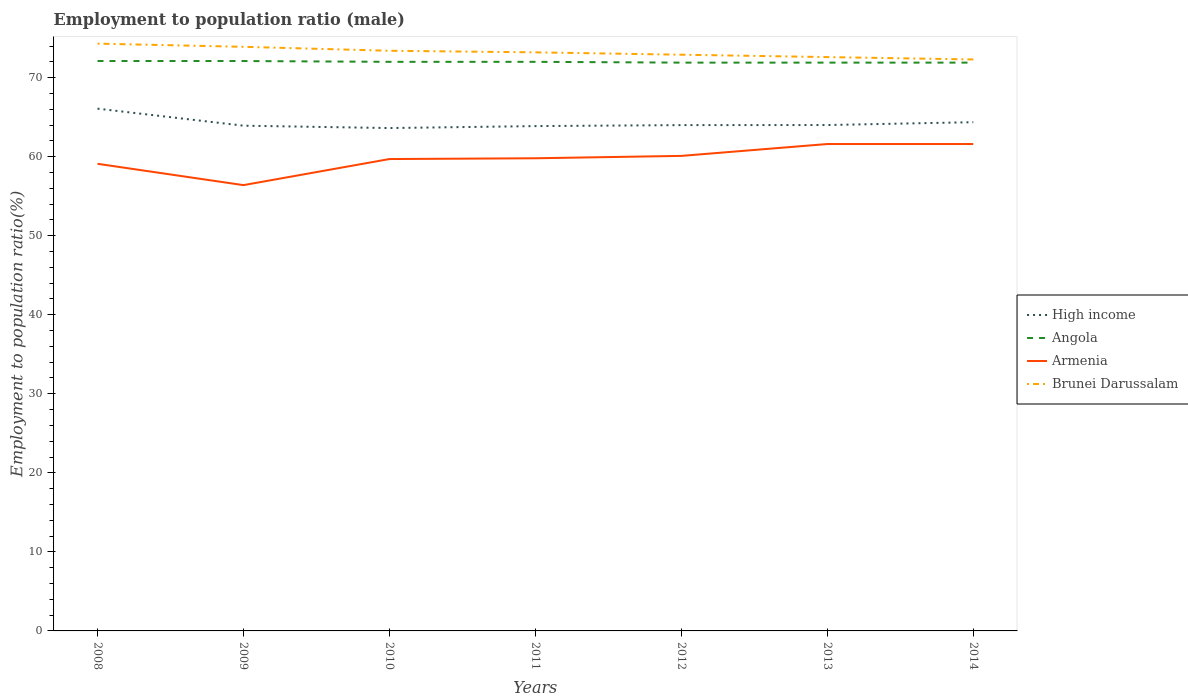Is the number of lines equal to the number of legend labels?
Offer a terse response. Yes. Across all years, what is the maximum employment to population ratio in Brunei Darussalam?
Ensure brevity in your answer.  72.3. What is the total employment to population ratio in Brunei Darussalam in the graph?
Make the answer very short. 0.6. What is the difference between the highest and the second highest employment to population ratio in High income?
Your answer should be compact. 2.46. Is the employment to population ratio in Angola strictly greater than the employment to population ratio in Brunei Darussalam over the years?
Offer a very short reply. Yes. What is the difference between two consecutive major ticks on the Y-axis?
Your response must be concise. 10. Are the values on the major ticks of Y-axis written in scientific E-notation?
Keep it short and to the point. No. Does the graph contain grids?
Your answer should be compact. No. How many legend labels are there?
Offer a terse response. 4. What is the title of the graph?
Make the answer very short. Employment to population ratio (male). Does "Mongolia" appear as one of the legend labels in the graph?
Your answer should be compact. No. What is the label or title of the Y-axis?
Your response must be concise. Employment to population ratio(%). What is the Employment to population ratio(%) of High income in 2008?
Make the answer very short. 66.08. What is the Employment to population ratio(%) in Angola in 2008?
Your answer should be compact. 72.1. What is the Employment to population ratio(%) of Armenia in 2008?
Keep it short and to the point. 59.1. What is the Employment to population ratio(%) of Brunei Darussalam in 2008?
Your answer should be very brief. 74.3. What is the Employment to population ratio(%) of High income in 2009?
Your response must be concise. 63.92. What is the Employment to population ratio(%) in Angola in 2009?
Make the answer very short. 72.1. What is the Employment to population ratio(%) of Armenia in 2009?
Keep it short and to the point. 56.4. What is the Employment to population ratio(%) in Brunei Darussalam in 2009?
Provide a succinct answer. 73.9. What is the Employment to population ratio(%) in High income in 2010?
Provide a succinct answer. 63.62. What is the Employment to population ratio(%) in Angola in 2010?
Provide a succinct answer. 72. What is the Employment to population ratio(%) of Armenia in 2010?
Keep it short and to the point. 59.7. What is the Employment to population ratio(%) of Brunei Darussalam in 2010?
Your answer should be compact. 73.4. What is the Employment to population ratio(%) of High income in 2011?
Keep it short and to the point. 63.87. What is the Employment to population ratio(%) of Angola in 2011?
Your answer should be very brief. 72. What is the Employment to population ratio(%) of Armenia in 2011?
Give a very brief answer. 59.8. What is the Employment to population ratio(%) of Brunei Darussalam in 2011?
Make the answer very short. 73.2. What is the Employment to population ratio(%) in High income in 2012?
Keep it short and to the point. 63.99. What is the Employment to population ratio(%) in Angola in 2012?
Ensure brevity in your answer.  71.9. What is the Employment to population ratio(%) of Armenia in 2012?
Ensure brevity in your answer.  60.1. What is the Employment to population ratio(%) of Brunei Darussalam in 2012?
Your answer should be very brief. 72.9. What is the Employment to population ratio(%) in High income in 2013?
Your answer should be compact. 64. What is the Employment to population ratio(%) of Angola in 2013?
Give a very brief answer. 71.9. What is the Employment to population ratio(%) in Armenia in 2013?
Ensure brevity in your answer.  61.6. What is the Employment to population ratio(%) of Brunei Darussalam in 2013?
Ensure brevity in your answer.  72.6. What is the Employment to population ratio(%) of High income in 2014?
Your response must be concise. 64.36. What is the Employment to population ratio(%) in Angola in 2014?
Offer a very short reply. 71.9. What is the Employment to population ratio(%) of Armenia in 2014?
Provide a short and direct response. 61.6. What is the Employment to population ratio(%) of Brunei Darussalam in 2014?
Provide a succinct answer. 72.3. Across all years, what is the maximum Employment to population ratio(%) in High income?
Your response must be concise. 66.08. Across all years, what is the maximum Employment to population ratio(%) in Angola?
Ensure brevity in your answer.  72.1. Across all years, what is the maximum Employment to population ratio(%) of Armenia?
Your answer should be very brief. 61.6. Across all years, what is the maximum Employment to population ratio(%) in Brunei Darussalam?
Make the answer very short. 74.3. Across all years, what is the minimum Employment to population ratio(%) of High income?
Your answer should be very brief. 63.62. Across all years, what is the minimum Employment to population ratio(%) in Angola?
Give a very brief answer. 71.9. Across all years, what is the minimum Employment to population ratio(%) of Armenia?
Offer a very short reply. 56.4. Across all years, what is the minimum Employment to population ratio(%) of Brunei Darussalam?
Your answer should be compact. 72.3. What is the total Employment to population ratio(%) in High income in the graph?
Your response must be concise. 449.85. What is the total Employment to population ratio(%) in Angola in the graph?
Offer a very short reply. 503.9. What is the total Employment to population ratio(%) of Armenia in the graph?
Make the answer very short. 418.3. What is the total Employment to population ratio(%) of Brunei Darussalam in the graph?
Ensure brevity in your answer.  512.6. What is the difference between the Employment to population ratio(%) of High income in 2008 and that in 2009?
Keep it short and to the point. 2.16. What is the difference between the Employment to population ratio(%) of Angola in 2008 and that in 2009?
Provide a short and direct response. 0. What is the difference between the Employment to population ratio(%) in Armenia in 2008 and that in 2009?
Provide a succinct answer. 2.7. What is the difference between the Employment to population ratio(%) of Brunei Darussalam in 2008 and that in 2009?
Provide a succinct answer. 0.4. What is the difference between the Employment to population ratio(%) of High income in 2008 and that in 2010?
Your answer should be compact. 2.46. What is the difference between the Employment to population ratio(%) of High income in 2008 and that in 2011?
Give a very brief answer. 2.21. What is the difference between the Employment to population ratio(%) in Angola in 2008 and that in 2011?
Make the answer very short. 0.1. What is the difference between the Employment to population ratio(%) of Armenia in 2008 and that in 2011?
Offer a terse response. -0.7. What is the difference between the Employment to population ratio(%) in High income in 2008 and that in 2012?
Your response must be concise. 2.08. What is the difference between the Employment to population ratio(%) in High income in 2008 and that in 2013?
Offer a very short reply. 2.07. What is the difference between the Employment to population ratio(%) of Brunei Darussalam in 2008 and that in 2013?
Your response must be concise. 1.7. What is the difference between the Employment to population ratio(%) in High income in 2008 and that in 2014?
Give a very brief answer. 1.71. What is the difference between the Employment to population ratio(%) in Brunei Darussalam in 2008 and that in 2014?
Give a very brief answer. 2. What is the difference between the Employment to population ratio(%) of High income in 2009 and that in 2010?
Your response must be concise. 0.3. What is the difference between the Employment to population ratio(%) in Armenia in 2009 and that in 2010?
Give a very brief answer. -3.3. What is the difference between the Employment to population ratio(%) in High income in 2009 and that in 2011?
Your answer should be compact. 0.05. What is the difference between the Employment to population ratio(%) in Angola in 2009 and that in 2011?
Provide a short and direct response. 0.1. What is the difference between the Employment to population ratio(%) of Brunei Darussalam in 2009 and that in 2011?
Your response must be concise. 0.7. What is the difference between the Employment to population ratio(%) in High income in 2009 and that in 2012?
Ensure brevity in your answer.  -0.07. What is the difference between the Employment to population ratio(%) in Brunei Darussalam in 2009 and that in 2012?
Your answer should be very brief. 1. What is the difference between the Employment to population ratio(%) of High income in 2009 and that in 2013?
Provide a succinct answer. -0.08. What is the difference between the Employment to population ratio(%) of Angola in 2009 and that in 2013?
Offer a very short reply. 0.2. What is the difference between the Employment to population ratio(%) in High income in 2009 and that in 2014?
Offer a terse response. -0.44. What is the difference between the Employment to population ratio(%) in Armenia in 2009 and that in 2014?
Keep it short and to the point. -5.2. What is the difference between the Employment to population ratio(%) of Brunei Darussalam in 2009 and that in 2014?
Offer a terse response. 1.6. What is the difference between the Employment to population ratio(%) of High income in 2010 and that in 2011?
Offer a very short reply. -0.25. What is the difference between the Employment to population ratio(%) in Armenia in 2010 and that in 2011?
Make the answer very short. -0.1. What is the difference between the Employment to population ratio(%) of High income in 2010 and that in 2012?
Your response must be concise. -0.37. What is the difference between the Employment to population ratio(%) in Angola in 2010 and that in 2012?
Your response must be concise. 0.1. What is the difference between the Employment to population ratio(%) of Armenia in 2010 and that in 2012?
Make the answer very short. -0.4. What is the difference between the Employment to population ratio(%) in Brunei Darussalam in 2010 and that in 2012?
Provide a succinct answer. 0.5. What is the difference between the Employment to population ratio(%) of High income in 2010 and that in 2013?
Your response must be concise. -0.38. What is the difference between the Employment to population ratio(%) in Angola in 2010 and that in 2013?
Your answer should be compact. 0.1. What is the difference between the Employment to population ratio(%) in High income in 2010 and that in 2014?
Your answer should be very brief. -0.74. What is the difference between the Employment to population ratio(%) in Angola in 2010 and that in 2014?
Provide a succinct answer. 0.1. What is the difference between the Employment to population ratio(%) in High income in 2011 and that in 2012?
Make the answer very short. -0.12. What is the difference between the Employment to population ratio(%) of Brunei Darussalam in 2011 and that in 2012?
Make the answer very short. 0.3. What is the difference between the Employment to population ratio(%) in High income in 2011 and that in 2013?
Give a very brief answer. -0.13. What is the difference between the Employment to population ratio(%) in Armenia in 2011 and that in 2013?
Make the answer very short. -1.8. What is the difference between the Employment to population ratio(%) of High income in 2011 and that in 2014?
Offer a very short reply. -0.49. What is the difference between the Employment to population ratio(%) in Armenia in 2011 and that in 2014?
Provide a short and direct response. -1.8. What is the difference between the Employment to population ratio(%) in Brunei Darussalam in 2011 and that in 2014?
Your answer should be compact. 0.9. What is the difference between the Employment to population ratio(%) of High income in 2012 and that in 2013?
Your answer should be compact. -0.01. What is the difference between the Employment to population ratio(%) of Angola in 2012 and that in 2013?
Your response must be concise. 0. What is the difference between the Employment to population ratio(%) of Armenia in 2012 and that in 2013?
Provide a short and direct response. -1.5. What is the difference between the Employment to population ratio(%) in High income in 2012 and that in 2014?
Provide a short and direct response. -0.37. What is the difference between the Employment to population ratio(%) in Angola in 2012 and that in 2014?
Give a very brief answer. 0. What is the difference between the Employment to population ratio(%) of Armenia in 2012 and that in 2014?
Offer a very short reply. -1.5. What is the difference between the Employment to population ratio(%) of High income in 2013 and that in 2014?
Ensure brevity in your answer.  -0.36. What is the difference between the Employment to population ratio(%) in Angola in 2013 and that in 2014?
Keep it short and to the point. 0. What is the difference between the Employment to population ratio(%) of High income in 2008 and the Employment to population ratio(%) of Angola in 2009?
Offer a very short reply. -6.02. What is the difference between the Employment to population ratio(%) in High income in 2008 and the Employment to population ratio(%) in Armenia in 2009?
Your response must be concise. 9.68. What is the difference between the Employment to population ratio(%) in High income in 2008 and the Employment to population ratio(%) in Brunei Darussalam in 2009?
Your response must be concise. -7.82. What is the difference between the Employment to population ratio(%) in Angola in 2008 and the Employment to population ratio(%) in Armenia in 2009?
Make the answer very short. 15.7. What is the difference between the Employment to population ratio(%) of Angola in 2008 and the Employment to population ratio(%) of Brunei Darussalam in 2009?
Your answer should be compact. -1.8. What is the difference between the Employment to population ratio(%) of Armenia in 2008 and the Employment to population ratio(%) of Brunei Darussalam in 2009?
Ensure brevity in your answer.  -14.8. What is the difference between the Employment to population ratio(%) in High income in 2008 and the Employment to population ratio(%) in Angola in 2010?
Offer a terse response. -5.92. What is the difference between the Employment to population ratio(%) of High income in 2008 and the Employment to population ratio(%) of Armenia in 2010?
Your response must be concise. 6.38. What is the difference between the Employment to population ratio(%) of High income in 2008 and the Employment to population ratio(%) of Brunei Darussalam in 2010?
Offer a very short reply. -7.32. What is the difference between the Employment to population ratio(%) in Angola in 2008 and the Employment to population ratio(%) in Armenia in 2010?
Your answer should be very brief. 12.4. What is the difference between the Employment to population ratio(%) in Angola in 2008 and the Employment to population ratio(%) in Brunei Darussalam in 2010?
Make the answer very short. -1.3. What is the difference between the Employment to population ratio(%) in Armenia in 2008 and the Employment to population ratio(%) in Brunei Darussalam in 2010?
Ensure brevity in your answer.  -14.3. What is the difference between the Employment to population ratio(%) of High income in 2008 and the Employment to population ratio(%) of Angola in 2011?
Provide a succinct answer. -5.92. What is the difference between the Employment to population ratio(%) of High income in 2008 and the Employment to population ratio(%) of Armenia in 2011?
Your answer should be very brief. 6.28. What is the difference between the Employment to population ratio(%) of High income in 2008 and the Employment to population ratio(%) of Brunei Darussalam in 2011?
Your response must be concise. -7.12. What is the difference between the Employment to population ratio(%) of Angola in 2008 and the Employment to population ratio(%) of Armenia in 2011?
Provide a short and direct response. 12.3. What is the difference between the Employment to population ratio(%) of Armenia in 2008 and the Employment to population ratio(%) of Brunei Darussalam in 2011?
Your response must be concise. -14.1. What is the difference between the Employment to population ratio(%) in High income in 2008 and the Employment to population ratio(%) in Angola in 2012?
Give a very brief answer. -5.82. What is the difference between the Employment to population ratio(%) in High income in 2008 and the Employment to population ratio(%) in Armenia in 2012?
Ensure brevity in your answer.  5.98. What is the difference between the Employment to population ratio(%) in High income in 2008 and the Employment to population ratio(%) in Brunei Darussalam in 2012?
Offer a terse response. -6.82. What is the difference between the Employment to population ratio(%) in Angola in 2008 and the Employment to population ratio(%) in Armenia in 2012?
Your answer should be compact. 12. What is the difference between the Employment to population ratio(%) in Angola in 2008 and the Employment to population ratio(%) in Brunei Darussalam in 2012?
Your answer should be very brief. -0.8. What is the difference between the Employment to population ratio(%) of Armenia in 2008 and the Employment to population ratio(%) of Brunei Darussalam in 2012?
Your answer should be very brief. -13.8. What is the difference between the Employment to population ratio(%) of High income in 2008 and the Employment to population ratio(%) of Angola in 2013?
Your answer should be compact. -5.82. What is the difference between the Employment to population ratio(%) of High income in 2008 and the Employment to population ratio(%) of Armenia in 2013?
Your answer should be very brief. 4.48. What is the difference between the Employment to population ratio(%) in High income in 2008 and the Employment to population ratio(%) in Brunei Darussalam in 2013?
Provide a short and direct response. -6.52. What is the difference between the Employment to population ratio(%) in Angola in 2008 and the Employment to population ratio(%) in Armenia in 2013?
Provide a succinct answer. 10.5. What is the difference between the Employment to population ratio(%) of Angola in 2008 and the Employment to population ratio(%) of Brunei Darussalam in 2013?
Ensure brevity in your answer.  -0.5. What is the difference between the Employment to population ratio(%) in High income in 2008 and the Employment to population ratio(%) in Angola in 2014?
Your response must be concise. -5.82. What is the difference between the Employment to population ratio(%) of High income in 2008 and the Employment to population ratio(%) of Armenia in 2014?
Ensure brevity in your answer.  4.48. What is the difference between the Employment to population ratio(%) in High income in 2008 and the Employment to population ratio(%) in Brunei Darussalam in 2014?
Make the answer very short. -6.22. What is the difference between the Employment to population ratio(%) of Angola in 2008 and the Employment to population ratio(%) of Armenia in 2014?
Provide a short and direct response. 10.5. What is the difference between the Employment to population ratio(%) of Armenia in 2008 and the Employment to population ratio(%) of Brunei Darussalam in 2014?
Your answer should be very brief. -13.2. What is the difference between the Employment to population ratio(%) in High income in 2009 and the Employment to population ratio(%) in Angola in 2010?
Your answer should be very brief. -8.08. What is the difference between the Employment to population ratio(%) in High income in 2009 and the Employment to population ratio(%) in Armenia in 2010?
Your answer should be very brief. 4.22. What is the difference between the Employment to population ratio(%) in High income in 2009 and the Employment to population ratio(%) in Brunei Darussalam in 2010?
Keep it short and to the point. -9.48. What is the difference between the Employment to population ratio(%) in Angola in 2009 and the Employment to population ratio(%) in Armenia in 2010?
Provide a short and direct response. 12.4. What is the difference between the Employment to population ratio(%) of Armenia in 2009 and the Employment to population ratio(%) of Brunei Darussalam in 2010?
Provide a short and direct response. -17. What is the difference between the Employment to population ratio(%) in High income in 2009 and the Employment to population ratio(%) in Angola in 2011?
Give a very brief answer. -8.08. What is the difference between the Employment to population ratio(%) of High income in 2009 and the Employment to population ratio(%) of Armenia in 2011?
Provide a short and direct response. 4.12. What is the difference between the Employment to population ratio(%) of High income in 2009 and the Employment to population ratio(%) of Brunei Darussalam in 2011?
Give a very brief answer. -9.28. What is the difference between the Employment to population ratio(%) of Angola in 2009 and the Employment to population ratio(%) of Armenia in 2011?
Keep it short and to the point. 12.3. What is the difference between the Employment to population ratio(%) in Angola in 2009 and the Employment to population ratio(%) in Brunei Darussalam in 2011?
Your answer should be very brief. -1.1. What is the difference between the Employment to population ratio(%) in Armenia in 2009 and the Employment to population ratio(%) in Brunei Darussalam in 2011?
Your answer should be very brief. -16.8. What is the difference between the Employment to population ratio(%) of High income in 2009 and the Employment to population ratio(%) of Angola in 2012?
Ensure brevity in your answer.  -7.98. What is the difference between the Employment to population ratio(%) in High income in 2009 and the Employment to population ratio(%) in Armenia in 2012?
Offer a terse response. 3.82. What is the difference between the Employment to population ratio(%) in High income in 2009 and the Employment to population ratio(%) in Brunei Darussalam in 2012?
Your answer should be compact. -8.98. What is the difference between the Employment to population ratio(%) of Armenia in 2009 and the Employment to population ratio(%) of Brunei Darussalam in 2012?
Give a very brief answer. -16.5. What is the difference between the Employment to population ratio(%) in High income in 2009 and the Employment to population ratio(%) in Angola in 2013?
Give a very brief answer. -7.98. What is the difference between the Employment to population ratio(%) of High income in 2009 and the Employment to population ratio(%) of Armenia in 2013?
Keep it short and to the point. 2.32. What is the difference between the Employment to population ratio(%) of High income in 2009 and the Employment to population ratio(%) of Brunei Darussalam in 2013?
Provide a short and direct response. -8.68. What is the difference between the Employment to population ratio(%) of Angola in 2009 and the Employment to population ratio(%) of Armenia in 2013?
Offer a terse response. 10.5. What is the difference between the Employment to population ratio(%) in Angola in 2009 and the Employment to population ratio(%) in Brunei Darussalam in 2013?
Keep it short and to the point. -0.5. What is the difference between the Employment to population ratio(%) in Armenia in 2009 and the Employment to population ratio(%) in Brunei Darussalam in 2013?
Your answer should be compact. -16.2. What is the difference between the Employment to population ratio(%) in High income in 2009 and the Employment to population ratio(%) in Angola in 2014?
Offer a terse response. -7.98. What is the difference between the Employment to population ratio(%) in High income in 2009 and the Employment to population ratio(%) in Armenia in 2014?
Provide a short and direct response. 2.32. What is the difference between the Employment to population ratio(%) of High income in 2009 and the Employment to population ratio(%) of Brunei Darussalam in 2014?
Offer a very short reply. -8.38. What is the difference between the Employment to population ratio(%) in Angola in 2009 and the Employment to population ratio(%) in Armenia in 2014?
Provide a succinct answer. 10.5. What is the difference between the Employment to population ratio(%) in Angola in 2009 and the Employment to population ratio(%) in Brunei Darussalam in 2014?
Provide a short and direct response. -0.2. What is the difference between the Employment to population ratio(%) in Armenia in 2009 and the Employment to population ratio(%) in Brunei Darussalam in 2014?
Offer a terse response. -15.9. What is the difference between the Employment to population ratio(%) of High income in 2010 and the Employment to population ratio(%) of Angola in 2011?
Make the answer very short. -8.38. What is the difference between the Employment to population ratio(%) of High income in 2010 and the Employment to population ratio(%) of Armenia in 2011?
Keep it short and to the point. 3.82. What is the difference between the Employment to population ratio(%) of High income in 2010 and the Employment to population ratio(%) of Brunei Darussalam in 2011?
Ensure brevity in your answer.  -9.58. What is the difference between the Employment to population ratio(%) of High income in 2010 and the Employment to population ratio(%) of Angola in 2012?
Give a very brief answer. -8.28. What is the difference between the Employment to population ratio(%) in High income in 2010 and the Employment to population ratio(%) in Armenia in 2012?
Make the answer very short. 3.52. What is the difference between the Employment to population ratio(%) in High income in 2010 and the Employment to population ratio(%) in Brunei Darussalam in 2012?
Make the answer very short. -9.28. What is the difference between the Employment to population ratio(%) of Angola in 2010 and the Employment to population ratio(%) of Brunei Darussalam in 2012?
Ensure brevity in your answer.  -0.9. What is the difference between the Employment to population ratio(%) of Armenia in 2010 and the Employment to population ratio(%) of Brunei Darussalam in 2012?
Provide a short and direct response. -13.2. What is the difference between the Employment to population ratio(%) in High income in 2010 and the Employment to population ratio(%) in Angola in 2013?
Offer a very short reply. -8.28. What is the difference between the Employment to population ratio(%) in High income in 2010 and the Employment to population ratio(%) in Armenia in 2013?
Your answer should be very brief. 2.02. What is the difference between the Employment to population ratio(%) in High income in 2010 and the Employment to population ratio(%) in Brunei Darussalam in 2013?
Your response must be concise. -8.98. What is the difference between the Employment to population ratio(%) of Armenia in 2010 and the Employment to population ratio(%) of Brunei Darussalam in 2013?
Your answer should be very brief. -12.9. What is the difference between the Employment to population ratio(%) of High income in 2010 and the Employment to population ratio(%) of Angola in 2014?
Make the answer very short. -8.28. What is the difference between the Employment to population ratio(%) of High income in 2010 and the Employment to population ratio(%) of Armenia in 2014?
Offer a very short reply. 2.02. What is the difference between the Employment to population ratio(%) of High income in 2010 and the Employment to population ratio(%) of Brunei Darussalam in 2014?
Offer a very short reply. -8.68. What is the difference between the Employment to population ratio(%) of Angola in 2010 and the Employment to population ratio(%) of Brunei Darussalam in 2014?
Your response must be concise. -0.3. What is the difference between the Employment to population ratio(%) in High income in 2011 and the Employment to population ratio(%) in Angola in 2012?
Provide a succinct answer. -8.03. What is the difference between the Employment to population ratio(%) in High income in 2011 and the Employment to population ratio(%) in Armenia in 2012?
Keep it short and to the point. 3.77. What is the difference between the Employment to population ratio(%) of High income in 2011 and the Employment to population ratio(%) of Brunei Darussalam in 2012?
Offer a terse response. -9.03. What is the difference between the Employment to population ratio(%) in Angola in 2011 and the Employment to population ratio(%) in Armenia in 2012?
Your response must be concise. 11.9. What is the difference between the Employment to population ratio(%) in Armenia in 2011 and the Employment to population ratio(%) in Brunei Darussalam in 2012?
Your answer should be very brief. -13.1. What is the difference between the Employment to population ratio(%) in High income in 2011 and the Employment to population ratio(%) in Angola in 2013?
Offer a very short reply. -8.03. What is the difference between the Employment to population ratio(%) in High income in 2011 and the Employment to population ratio(%) in Armenia in 2013?
Provide a short and direct response. 2.27. What is the difference between the Employment to population ratio(%) in High income in 2011 and the Employment to population ratio(%) in Brunei Darussalam in 2013?
Your answer should be very brief. -8.73. What is the difference between the Employment to population ratio(%) in Angola in 2011 and the Employment to population ratio(%) in Armenia in 2013?
Offer a terse response. 10.4. What is the difference between the Employment to population ratio(%) in Angola in 2011 and the Employment to population ratio(%) in Brunei Darussalam in 2013?
Ensure brevity in your answer.  -0.6. What is the difference between the Employment to population ratio(%) of High income in 2011 and the Employment to population ratio(%) of Angola in 2014?
Your answer should be compact. -8.03. What is the difference between the Employment to population ratio(%) in High income in 2011 and the Employment to population ratio(%) in Armenia in 2014?
Offer a very short reply. 2.27. What is the difference between the Employment to population ratio(%) of High income in 2011 and the Employment to population ratio(%) of Brunei Darussalam in 2014?
Keep it short and to the point. -8.43. What is the difference between the Employment to population ratio(%) in Angola in 2011 and the Employment to population ratio(%) in Brunei Darussalam in 2014?
Offer a very short reply. -0.3. What is the difference between the Employment to population ratio(%) of High income in 2012 and the Employment to population ratio(%) of Angola in 2013?
Offer a very short reply. -7.91. What is the difference between the Employment to population ratio(%) in High income in 2012 and the Employment to population ratio(%) in Armenia in 2013?
Offer a very short reply. 2.39. What is the difference between the Employment to population ratio(%) of High income in 2012 and the Employment to population ratio(%) of Brunei Darussalam in 2013?
Provide a succinct answer. -8.61. What is the difference between the Employment to population ratio(%) of Angola in 2012 and the Employment to population ratio(%) of Armenia in 2013?
Offer a terse response. 10.3. What is the difference between the Employment to population ratio(%) in High income in 2012 and the Employment to population ratio(%) in Angola in 2014?
Give a very brief answer. -7.91. What is the difference between the Employment to population ratio(%) of High income in 2012 and the Employment to population ratio(%) of Armenia in 2014?
Provide a short and direct response. 2.39. What is the difference between the Employment to population ratio(%) of High income in 2012 and the Employment to population ratio(%) of Brunei Darussalam in 2014?
Provide a succinct answer. -8.31. What is the difference between the Employment to population ratio(%) in Angola in 2012 and the Employment to population ratio(%) in Armenia in 2014?
Offer a very short reply. 10.3. What is the difference between the Employment to population ratio(%) in High income in 2013 and the Employment to population ratio(%) in Angola in 2014?
Provide a succinct answer. -7.9. What is the difference between the Employment to population ratio(%) of High income in 2013 and the Employment to population ratio(%) of Armenia in 2014?
Your answer should be compact. 2.4. What is the difference between the Employment to population ratio(%) in High income in 2013 and the Employment to population ratio(%) in Brunei Darussalam in 2014?
Make the answer very short. -8.3. What is the difference between the Employment to population ratio(%) in Angola in 2013 and the Employment to population ratio(%) in Brunei Darussalam in 2014?
Your response must be concise. -0.4. What is the average Employment to population ratio(%) of High income per year?
Your response must be concise. 64.26. What is the average Employment to population ratio(%) of Angola per year?
Give a very brief answer. 71.99. What is the average Employment to population ratio(%) of Armenia per year?
Ensure brevity in your answer.  59.76. What is the average Employment to population ratio(%) of Brunei Darussalam per year?
Your answer should be compact. 73.23. In the year 2008, what is the difference between the Employment to population ratio(%) of High income and Employment to population ratio(%) of Angola?
Your answer should be very brief. -6.02. In the year 2008, what is the difference between the Employment to population ratio(%) of High income and Employment to population ratio(%) of Armenia?
Your answer should be very brief. 6.98. In the year 2008, what is the difference between the Employment to population ratio(%) of High income and Employment to population ratio(%) of Brunei Darussalam?
Offer a terse response. -8.22. In the year 2008, what is the difference between the Employment to population ratio(%) of Angola and Employment to population ratio(%) of Brunei Darussalam?
Give a very brief answer. -2.2. In the year 2008, what is the difference between the Employment to population ratio(%) in Armenia and Employment to population ratio(%) in Brunei Darussalam?
Provide a succinct answer. -15.2. In the year 2009, what is the difference between the Employment to population ratio(%) in High income and Employment to population ratio(%) in Angola?
Offer a very short reply. -8.18. In the year 2009, what is the difference between the Employment to population ratio(%) in High income and Employment to population ratio(%) in Armenia?
Ensure brevity in your answer.  7.52. In the year 2009, what is the difference between the Employment to population ratio(%) of High income and Employment to population ratio(%) of Brunei Darussalam?
Keep it short and to the point. -9.98. In the year 2009, what is the difference between the Employment to population ratio(%) in Angola and Employment to population ratio(%) in Brunei Darussalam?
Make the answer very short. -1.8. In the year 2009, what is the difference between the Employment to population ratio(%) in Armenia and Employment to population ratio(%) in Brunei Darussalam?
Give a very brief answer. -17.5. In the year 2010, what is the difference between the Employment to population ratio(%) in High income and Employment to population ratio(%) in Angola?
Keep it short and to the point. -8.38. In the year 2010, what is the difference between the Employment to population ratio(%) in High income and Employment to population ratio(%) in Armenia?
Your response must be concise. 3.92. In the year 2010, what is the difference between the Employment to population ratio(%) in High income and Employment to population ratio(%) in Brunei Darussalam?
Keep it short and to the point. -9.78. In the year 2010, what is the difference between the Employment to population ratio(%) of Angola and Employment to population ratio(%) of Armenia?
Provide a short and direct response. 12.3. In the year 2010, what is the difference between the Employment to population ratio(%) of Angola and Employment to population ratio(%) of Brunei Darussalam?
Your answer should be very brief. -1.4. In the year 2010, what is the difference between the Employment to population ratio(%) of Armenia and Employment to population ratio(%) of Brunei Darussalam?
Your answer should be very brief. -13.7. In the year 2011, what is the difference between the Employment to population ratio(%) in High income and Employment to population ratio(%) in Angola?
Provide a succinct answer. -8.13. In the year 2011, what is the difference between the Employment to population ratio(%) in High income and Employment to population ratio(%) in Armenia?
Offer a very short reply. 4.07. In the year 2011, what is the difference between the Employment to population ratio(%) of High income and Employment to population ratio(%) of Brunei Darussalam?
Provide a succinct answer. -9.33. In the year 2012, what is the difference between the Employment to population ratio(%) of High income and Employment to population ratio(%) of Angola?
Your answer should be compact. -7.91. In the year 2012, what is the difference between the Employment to population ratio(%) of High income and Employment to population ratio(%) of Armenia?
Provide a succinct answer. 3.89. In the year 2012, what is the difference between the Employment to population ratio(%) in High income and Employment to population ratio(%) in Brunei Darussalam?
Your response must be concise. -8.91. In the year 2012, what is the difference between the Employment to population ratio(%) of Angola and Employment to population ratio(%) of Brunei Darussalam?
Provide a succinct answer. -1. In the year 2012, what is the difference between the Employment to population ratio(%) of Armenia and Employment to population ratio(%) of Brunei Darussalam?
Ensure brevity in your answer.  -12.8. In the year 2013, what is the difference between the Employment to population ratio(%) of High income and Employment to population ratio(%) of Angola?
Offer a very short reply. -7.9. In the year 2013, what is the difference between the Employment to population ratio(%) of High income and Employment to population ratio(%) of Armenia?
Make the answer very short. 2.4. In the year 2013, what is the difference between the Employment to population ratio(%) of High income and Employment to population ratio(%) of Brunei Darussalam?
Offer a very short reply. -8.6. In the year 2014, what is the difference between the Employment to population ratio(%) in High income and Employment to population ratio(%) in Angola?
Offer a very short reply. -7.54. In the year 2014, what is the difference between the Employment to population ratio(%) of High income and Employment to population ratio(%) of Armenia?
Make the answer very short. 2.76. In the year 2014, what is the difference between the Employment to population ratio(%) in High income and Employment to population ratio(%) in Brunei Darussalam?
Your answer should be compact. -7.94. What is the ratio of the Employment to population ratio(%) of High income in 2008 to that in 2009?
Keep it short and to the point. 1.03. What is the ratio of the Employment to population ratio(%) in Angola in 2008 to that in 2009?
Your answer should be compact. 1. What is the ratio of the Employment to population ratio(%) in Armenia in 2008 to that in 2009?
Your response must be concise. 1.05. What is the ratio of the Employment to population ratio(%) in Brunei Darussalam in 2008 to that in 2009?
Offer a very short reply. 1.01. What is the ratio of the Employment to population ratio(%) in High income in 2008 to that in 2010?
Make the answer very short. 1.04. What is the ratio of the Employment to population ratio(%) of Angola in 2008 to that in 2010?
Provide a succinct answer. 1. What is the ratio of the Employment to population ratio(%) in Armenia in 2008 to that in 2010?
Provide a short and direct response. 0.99. What is the ratio of the Employment to population ratio(%) of Brunei Darussalam in 2008 to that in 2010?
Offer a terse response. 1.01. What is the ratio of the Employment to population ratio(%) in High income in 2008 to that in 2011?
Offer a very short reply. 1.03. What is the ratio of the Employment to population ratio(%) of Armenia in 2008 to that in 2011?
Provide a succinct answer. 0.99. What is the ratio of the Employment to population ratio(%) of High income in 2008 to that in 2012?
Give a very brief answer. 1.03. What is the ratio of the Employment to population ratio(%) of Angola in 2008 to that in 2012?
Give a very brief answer. 1. What is the ratio of the Employment to population ratio(%) in Armenia in 2008 to that in 2012?
Give a very brief answer. 0.98. What is the ratio of the Employment to population ratio(%) in Brunei Darussalam in 2008 to that in 2012?
Your answer should be very brief. 1.02. What is the ratio of the Employment to population ratio(%) of High income in 2008 to that in 2013?
Ensure brevity in your answer.  1.03. What is the ratio of the Employment to population ratio(%) in Angola in 2008 to that in 2013?
Offer a very short reply. 1. What is the ratio of the Employment to population ratio(%) in Armenia in 2008 to that in 2013?
Ensure brevity in your answer.  0.96. What is the ratio of the Employment to population ratio(%) of Brunei Darussalam in 2008 to that in 2013?
Your answer should be very brief. 1.02. What is the ratio of the Employment to population ratio(%) in High income in 2008 to that in 2014?
Your response must be concise. 1.03. What is the ratio of the Employment to population ratio(%) in Angola in 2008 to that in 2014?
Provide a short and direct response. 1. What is the ratio of the Employment to population ratio(%) in Armenia in 2008 to that in 2014?
Keep it short and to the point. 0.96. What is the ratio of the Employment to population ratio(%) in Brunei Darussalam in 2008 to that in 2014?
Your response must be concise. 1.03. What is the ratio of the Employment to population ratio(%) of High income in 2009 to that in 2010?
Your answer should be very brief. 1. What is the ratio of the Employment to population ratio(%) of Armenia in 2009 to that in 2010?
Provide a short and direct response. 0.94. What is the ratio of the Employment to population ratio(%) in Brunei Darussalam in 2009 to that in 2010?
Provide a succinct answer. 1.01. What is the ratio of the Employment to population ratio(%) of High income in 2009 to that in 2011?
Ensure brevity in your answer.  1. What is the ratio of the Employment to population ratio(%) of Angola in 2009 to that in 2011?
Offer a very short reply. 1. What is the ratio of the Employment to population ratio(%) of Armenia in 2009 to that in 2011?
Make the answer very short. 0.94. What is the ratio of the Employment to population ratio(%) of Brunei Darussalam in 2009 to that in 2011?
Make the answer very short. 1.01. What is the ratio of the Employment to population ratio(%) of Armenia in 2009 to that in 2012?
Give a very brief answer. 0.94. What is the ratio of the Employment to population ratio(%) in Brunei Darussalam in 2009 to that in 2012?
Make the answer very short. 1.01. What is the ratio of the Employment to population ratio(%) in High income in 2009 to that in 2013?
Offer a very short reply. 1. What is the ratio of the Employment to population ratio(%) in Angola in 2009 to that in 2013?
Provide a succinct answer. 1. What is the ratio of the Employment to population ratio(%) of Armenia in 2009 to that in 2013?
Give a very brief answer. 0.92. What is the ratio of the Employment to population ratio(%) of Brunei Darussalam in 2009 to that in 2013?
Ensure brevity in your answer.  1.02. What is the ratio of the Employment to population ratio(%) of High income in 2009 to that in 2014?
Give a very brief answer. 0.99. What is the ratio of the Employment to population ratio(%) of Angola in 2009 to that in 2014?
Provide a succinct answer. 1. What is the ratio of the Employment to population ratio(%) of Armenia in 2009 to that in 2014?
Give a very brief answer. 0.92. What is the ratio of the Employment to population ratio(%) of Brunei Darussalam in 2009 to that in 2014?
Ensure brevity in your answer.  1.02. What is the ratio of the Employment to population ratio(%) in High income in 2010 to that in 2011?
Ensure brevity in your answer.  1. What is the ratio of the Employment to population ratio(%) of Angola in 2010 to that in 2011?
Keep it short and to the point. 1. What is the ratio of the Employment to population ratio(%) of Armenia in 2010 to that in 2011?
Give a very brief answer. 1. What is the ratio of the Employment to population ratio(%) of Brunei Darussalam in 2010 to that in 2011?
Your answer should be compact. 1. What is the ratio of the Employment to population ratio(%) in Brunei Darussalam in 2010 to that in 2012?
Give a very brief answer. 1.01. What is the ratio of the Employment to population ratio(%) in Angola in 2010 to that in 2013?
Provide a short and direct response. 1. What is the ratio of the Employment to population ratio(%) in Armenia in 2010 to that in 2013?
Offer a very short reply. 0.97. What is the ratio of the Employment to population ratio(%) of Brunei Darussalam in 2010 to that in 2013?
Keep it short and to the point. 1.01. What is the ratio of the Employment to population ratio(%) of Armenia in 2010 to that in 2014?
Keep it short and to the point. 0.97. What is the ratio of the Employment to population ratio(%) of Brunei Darussalam in 2010 to that in 2014?
Provide a short and direct response. 1.02. What is the ratio of the Employment to population ratio(%) of High income in 2011 to that in 2012?
Provide a succinct answer. 1. What is the ratio of the Employment to population ratio(%) in High income in 2011 to that in 2013?
Give a very brief answer. 1. What is the ratio of the Employment to population ratio(%) in Armenia in 2011 to that in 2013?
Your answer should be compact. 0.97. What is the ratio of the Employment to population ratio(%) of Brunei Darussalam in 2011 to that in 2013?
Offer a very short reply. 1.01. What is the ratio of the Employment to population ratio(%) of High income in 2011 to that in 2014?
Your answer should be compact. 0.99. What is the ratio of the Employment to population ratio(%) of Angola in 2011 to that in 2014?
Provide a succinct answer. 1. What is the ratio of the Employment to population ratio(%) of Armenia in 2011 to that in 2014?
Provide a short and direct response. 0.97. What is the ratio of the Employment to population ratio(%) in Brunei Darussalam in 2011 to that in 2014?
Ensure brevity in your answer.  1.01. What is the ratio of the Employment to population ratio(%) of High income in 2012 to that in 2013?
Keep it short and to the point. 1. What is the ratio of the Employment to population ratio(%) of Angola in 2012 to that in 2013?
Your answer should be very brief. 1. What is the ratio of the Employment to population ratio(%) of Armenia in 2012 to that in 2013?
Your response must be concise. 0.98. What is the ratio of the Employment to population ratio(%) of Angola in 2012 to that in 2014?
Provide a succinct answer. 1. What is the ratio of the Employment to population ratio(%) of Armenia in 2012 to that in 2014?
Your response must be concise. 0.98. What is the ratio of the Employment to population ratio(%) in Brunei Darussalam in 2012 to that in 2014?
Your answer should be compact. 1.01. What is the ratio of the Employment to population ratio(%) in High income in 2013 to that in 2014?
Ensure brevity in your answer.  0.99. What is the difference between the highest and the second highest Employment to population ratio(%) in High income?
Your answer should be compact. 1.71. What is the difference between the highest and the second highest Employment to population ratio(%) in Armenia?
Offer a terse response. 0. What is the difference between the highest and the second highest Employment to population ratio(%) of Brunei Darussalam?
Your answer should be very brief. 0.4. What is the difference between the highest and the lowest Employment to population ratio(%) of High income?
Provide a succinct answer. 2.46. What is the difference between the highest and the lowest Employment to population ratio(%) in Armenia?
Give a very brief answer. 5.2. What is the difference between the highest and the lowest Employment to population ratio(%) in Brunei Darussalam?
Ensure brevity in your answer.  2. 